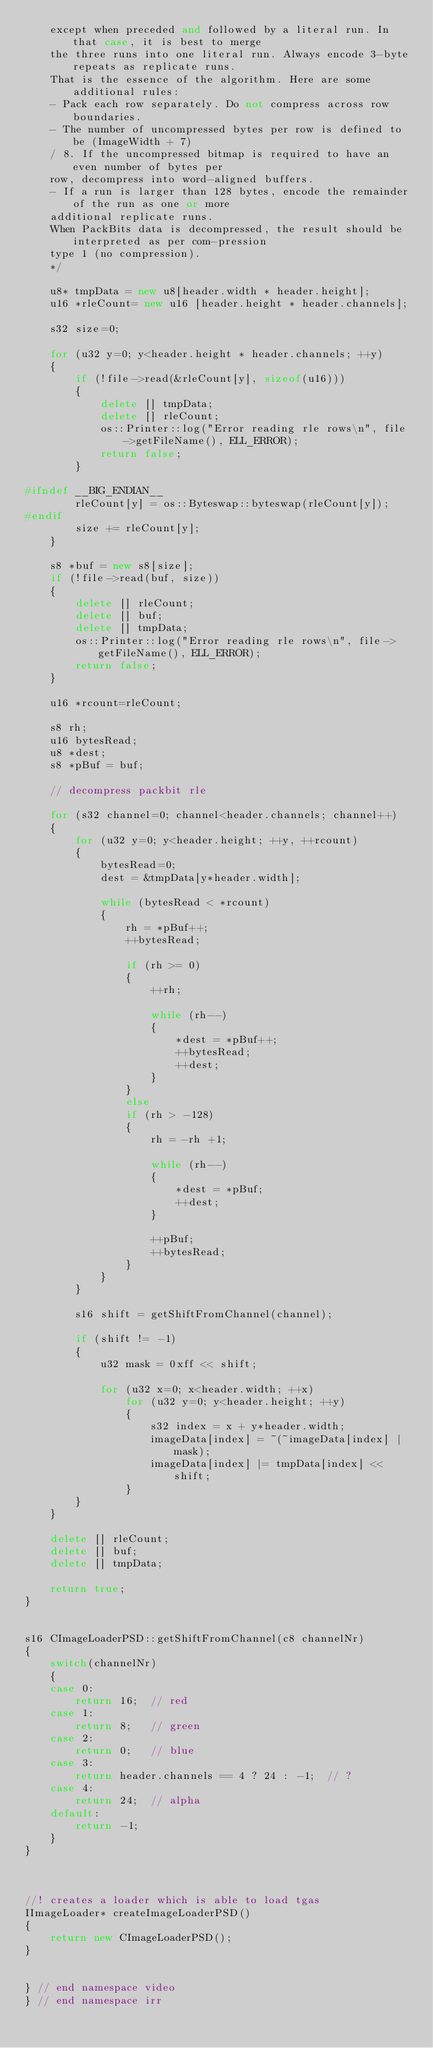<code> <loc_0><loc_0><loc_500><loc_500><_C++_>	except when preceded and followed by a literal run. In that case, it is best to merge
	the three runs into one literal run. Always encode 3-byte repeats as replicate runs.
	That is the essence of the algorithm. Here are some additional rules:
	- Pack each row separately. Do not compress across row boundaries.
	- The number of uncompressed bytes per row is defined to be (ImageWidth + 7)
	/ 8. If the uncompressed bitmap is required to have an even number of bytes per
	row, decompress into word-aligned buffers.
	- If a run is larger than 128 bytes, encode the remainder of the run as one or more
	additional replicate runs.
	When PackBits data is decompressed, the result should be interpreted as per com-pression
	type 1 (no compression).
	*/

	u8* tmpData = new u8[header.width * header.height];
	u16 *rleCount= new u16 [header.height * header.channels];

	s32 size=0;

	for (u32 y=0; y<header.height * header.channels; ++y)
	{
		if (!file->read(&rleCount[y], sizeof(u16)))
		{
			delete [] tmpData;
			delete [] rleCount;
			os::Printer::log("Error reading rle rows\n", file->getFileName(), ELL_ERROR);
			return false;
		}

#ifndef __BIG_ENDIAN__
		rleCount[y] = os::Byteswap::byteswap(rleCount[y]);
#endif
		size += rleCount[y];
	}

	s8 *buf = new s8[size];
	if (!file->read(buf, size))
	{
		delete [] rleCount;
		delete [] buf;
		delete [] tmpData;
		os::Printer::log("Error reading rle rows\n", file->getFileName(), ELL_ERROR);
		return false;
	}

	u16 *rcount=rleCount;

	s8 rh;
	u16 bytesRead;
	u8 *dest;
	s8 *pBuf = buf;

	// decompress packbit rle

	for (s32 channel=0; channel<header.channels; channel++)
	{
		for (u32 y=0; y<header.height; ++y, ++rcount)
		{
			bytesRead=0;
			dest = &tmpData[y*header.width];

			while (bytesRead < *rcount)
			{
				rh = *pBuf++;
				++bytesRead;

				if (rh >= 0)
				{
					++rh;

					while (rh--)
					{
						*dest = *pBuf++;
						++bytesRead;
						++dest;
					}
				}
				else
				if (rh > -128)
				{
					rh = -rh +1;

					while (rh--)
					{
						*dest = *pBuf;
						++dest;
					}

					++pBuf;
					++bytesRead;
				}
			}
		}

		s16 shift = getShiftFromChannel(channel);

		if (shift != -1)
		{
			u32 mask = 0xff << shift;

			for (u32 x=0; x<header.width; ++x)
				for (u32 y=0; y<header.height; ++y)
				{
					s32 index = x + y*header.width;
					imageData[index] = ~(~imageData[index] | mask);
					imageData[index] |= tmpData[index] << shift;
				}
		}
	}

	delete [] rleCount;
	delete [] buf;
	delete [] tmpData;

	return true;
}


s16 CImageLoaderPSD::getShiftFromChannel(c8 channelNr)
{
	switch(channelNr)
	{
	case 0:
		return 16;  // red
	case 1:
		return 8;   // green
	case 2:
		return 0;   // blue
	case 3:
		return header.channels == 4 ? 24 : -1;	// ?
	case 4:
		return 24;  // alpha
	default:
		return -1;
	}
}



//! creates a loader which is able to load tgas
IImageLoader* createImageLoaderPSD()
{
	return new CImageLoaderPSD();
}


} // end namespace video
} // end namespace irr

</code> 